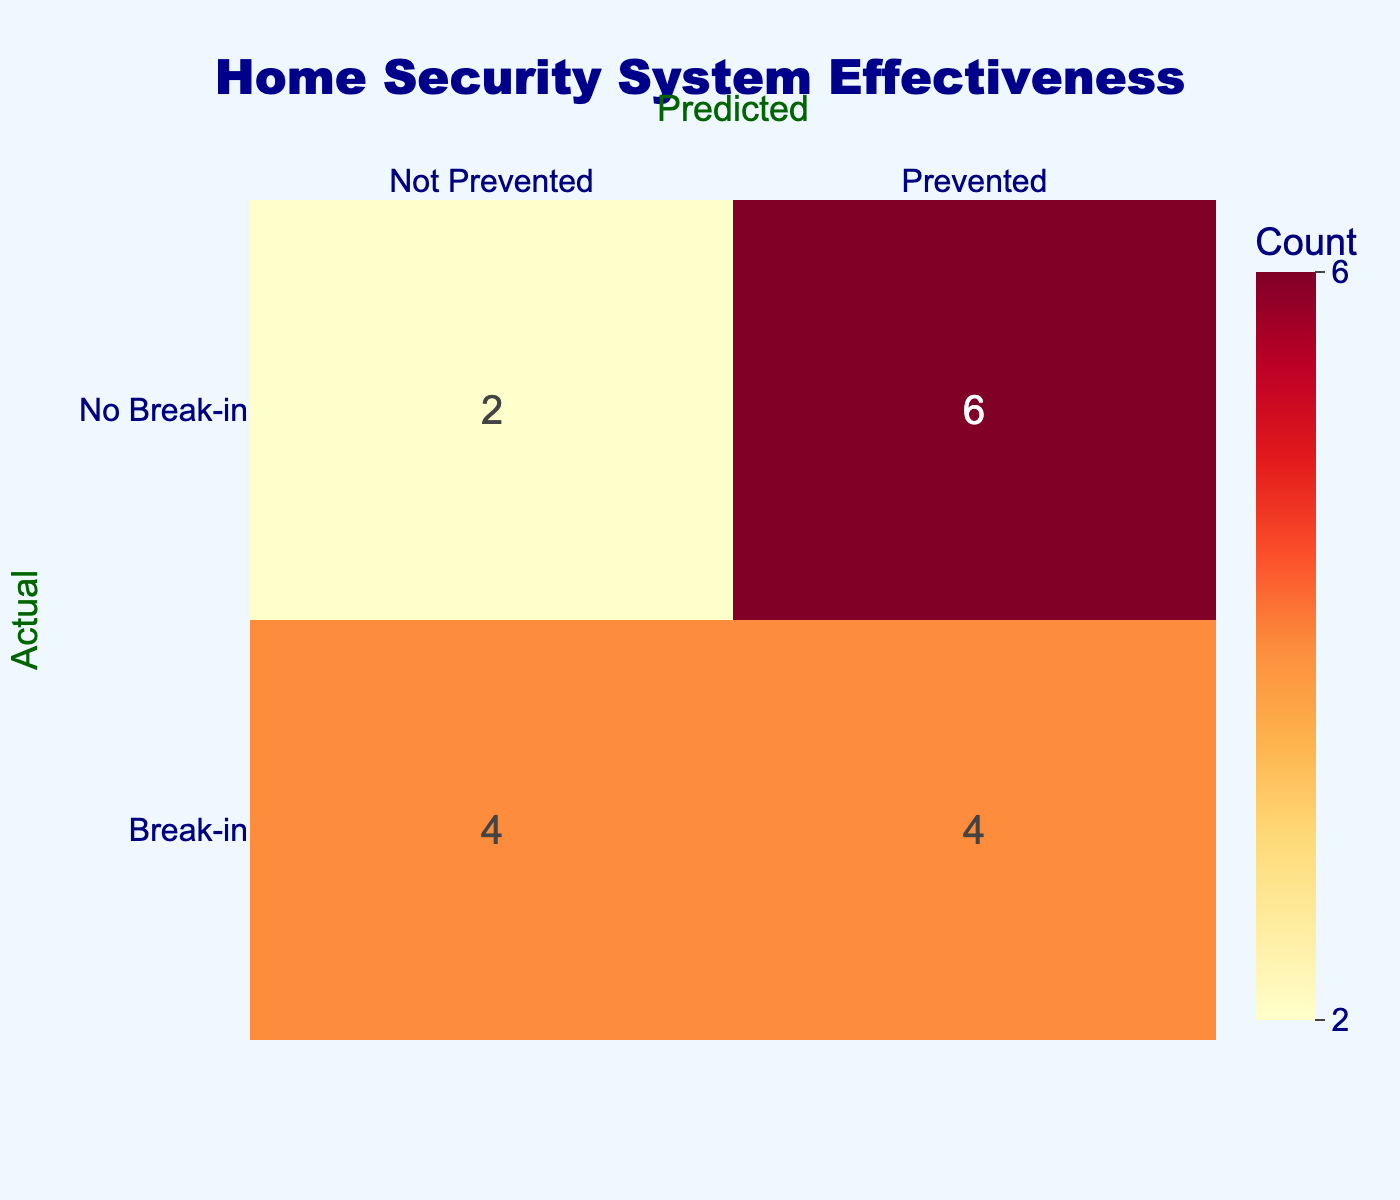What is the total number of Break-in instances predicted as Prevented? In the table, we look for the 'Break-in' row and the 'Prevented' column. There are 3 instances of 'Break-in' that are predicted as 'Prevented'.
Answer: 3 How many instances of No Break-in were incorrectly predicted as Not Prevented? We check the 'No Break-in' row and the 'Not Prevented' column. There is 1 instance where 'No Break-in' is predicted as 'Not Prevented'.
Answer: 1 What is the total number of No Break-in instances? To find this, we add the counts from both 'Prevented' and 'Not Prevented' for the 'No Break-in' row. There are 4 instances predicted as 'Prevented' and 2 as 'Not Prevented', totaling 6.
Answer: 6 Is it true that more Break-in instances were prevented than were not prevented? We compare the counts of Break-in predictions; there are 3 instances predicted as 'Prevented' and 4 predicted as 'Not Prevented', indicating that it is false.
Answer: No What is the difference in the number of actual Break-in cases that were predicted as Prevented compared to those that were not prevented? We find that 3 instances of 'Break-in' are predicted as 'Prevented', and 4 are predicted as 'Not Prevented'. The difference is 4 - 3 = 1 instance.
Answer: 1 How many total predictions were made that resulted in a No Break-in scenario? We sum up both columns for the 'No Break-in' row: 4 (Prevented) + 2 (Not Prevented) = 6 predictions.
Answer: 6 Was there an instance of No Break-in that was correctly predicted as Prevented? We look in the 'No Break-in' row under the 'Prevented' column. There are 4 instances where 'No Break-in' was predicted as 'Prevented', which means yes.
Answer: Yes What percentage of actual Break-ins were predicted as Prevented? There were 3 Break-ins predicted as 'Prevented' out of a total of 7 Break-in instances (3 predicted as 'Prevented' and 4 as 'Not Prevented'). The percentage is (3/7) * 100 ≈ 42.86%.
Answer: 42.86% What is the total count of predictions and how are they distributed among the four categories? We sum up all predictions: 3 + 4 (Break-in) + 4 + 2 (No Break-in) = 13 predictions in total. The distribution is 3 Prevented Break-in, 4 Not Prevented Break-in, 4 Prevented No Break-in, and 2 Not Prevented No Break-in.
Answer: 13 predictions, distributed: 3, 4, 4, 2 